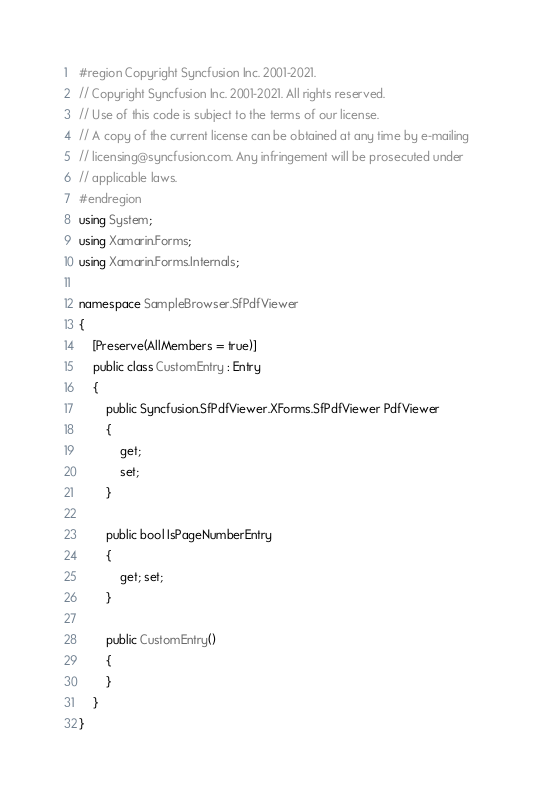<code> <loc_0><loc_0><loc_500><loc_500><_C#_>#region Copyright Syncfusion Inc. 2001-2021.
// Copyright Syncfusion Inc. 2001-2021. All rights reserved.
// Use of this code is subject to the terms of our license.
// A copy of the current license can be obtained at any time by e-mailing
// licensing@syncfusion.com. Any infringement will be prosecuted under
// applicable laws. 
#endregion
using System;
using Xamarin.Forms;
using Xamarin.Forms.Internals;

namespace SampleBrowser.SfPdfViewer
{
    [Preserve(AllMembers = true)]
    public class CustomEntry : Entry
    {
        public Syncfusion.SfPdfViewer.XForms.SfPdfViewer PdfViewer
        {
            get;
            set;
        }

        public bool IsPageNumberEntry
        {
            get; set;
        }

        public CustomEntry()
        {
        }
    }
}
</code> 